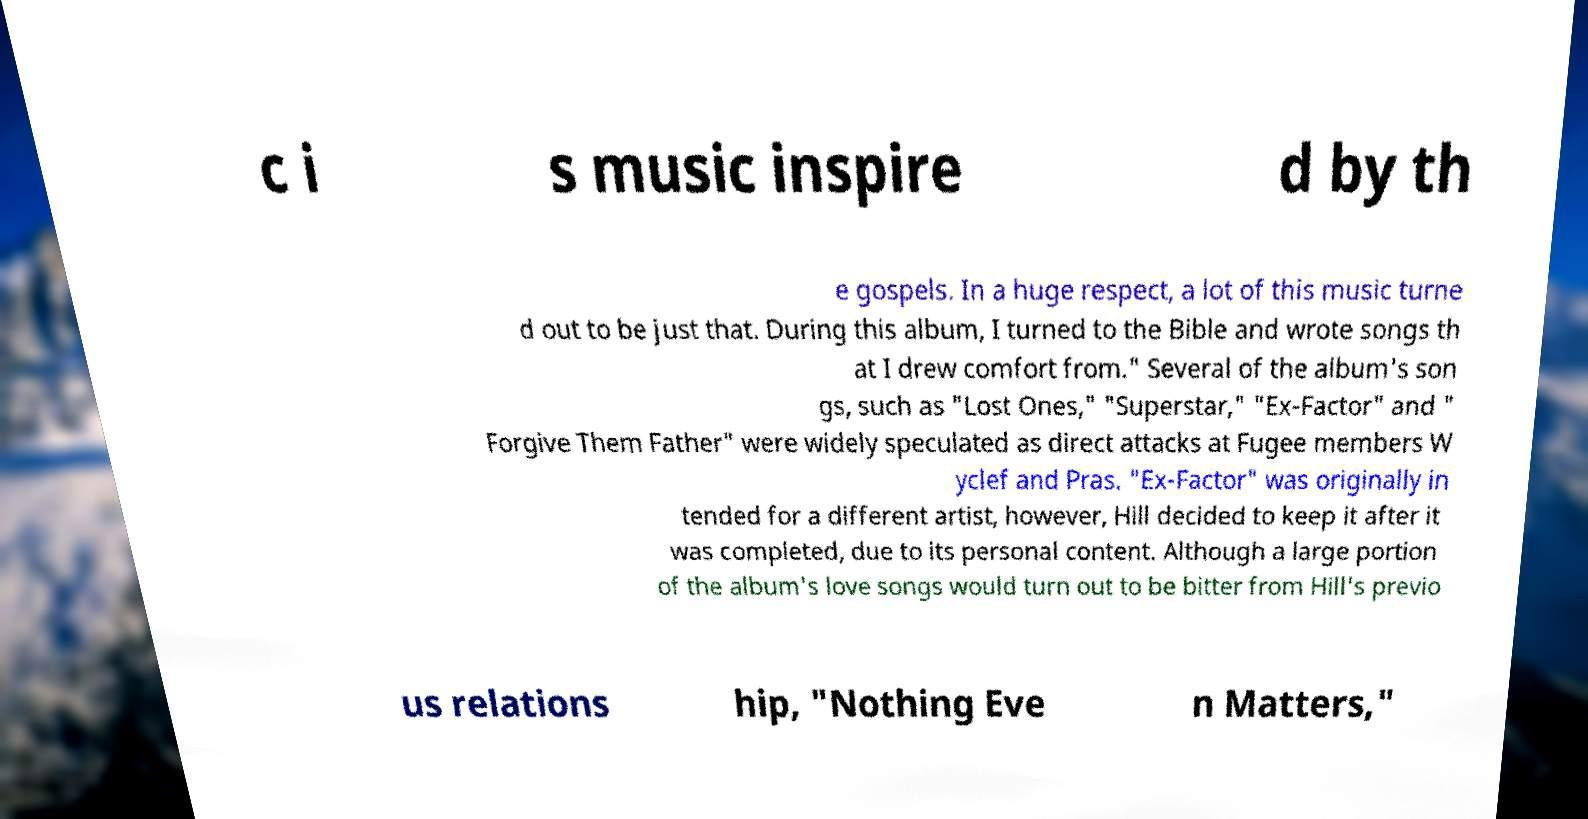Can you accurately transcribe the text from the provided image for me? c i s music inspire d by th e gospels. In a huge respect, a lot of this music turne d out to be just that. During this album, I turned to the Bible and wrote songs th at I drew comfort from." Several of the album's son gs, such as "Lost Ones," "Superstar," "Ex-Factor" and " Forgive Them Father" were widely speculated as direct attacks at Fugee members W yclef and Pras. "Ex-Factor" was originally in tended for a different artist, however, Hill decided to keep it after it was completed, due to its personal content. Although a large portion of the album's love songs would turn out to be bitter from Hill's previo us relations hip, "Nothing Eve n Matters," 